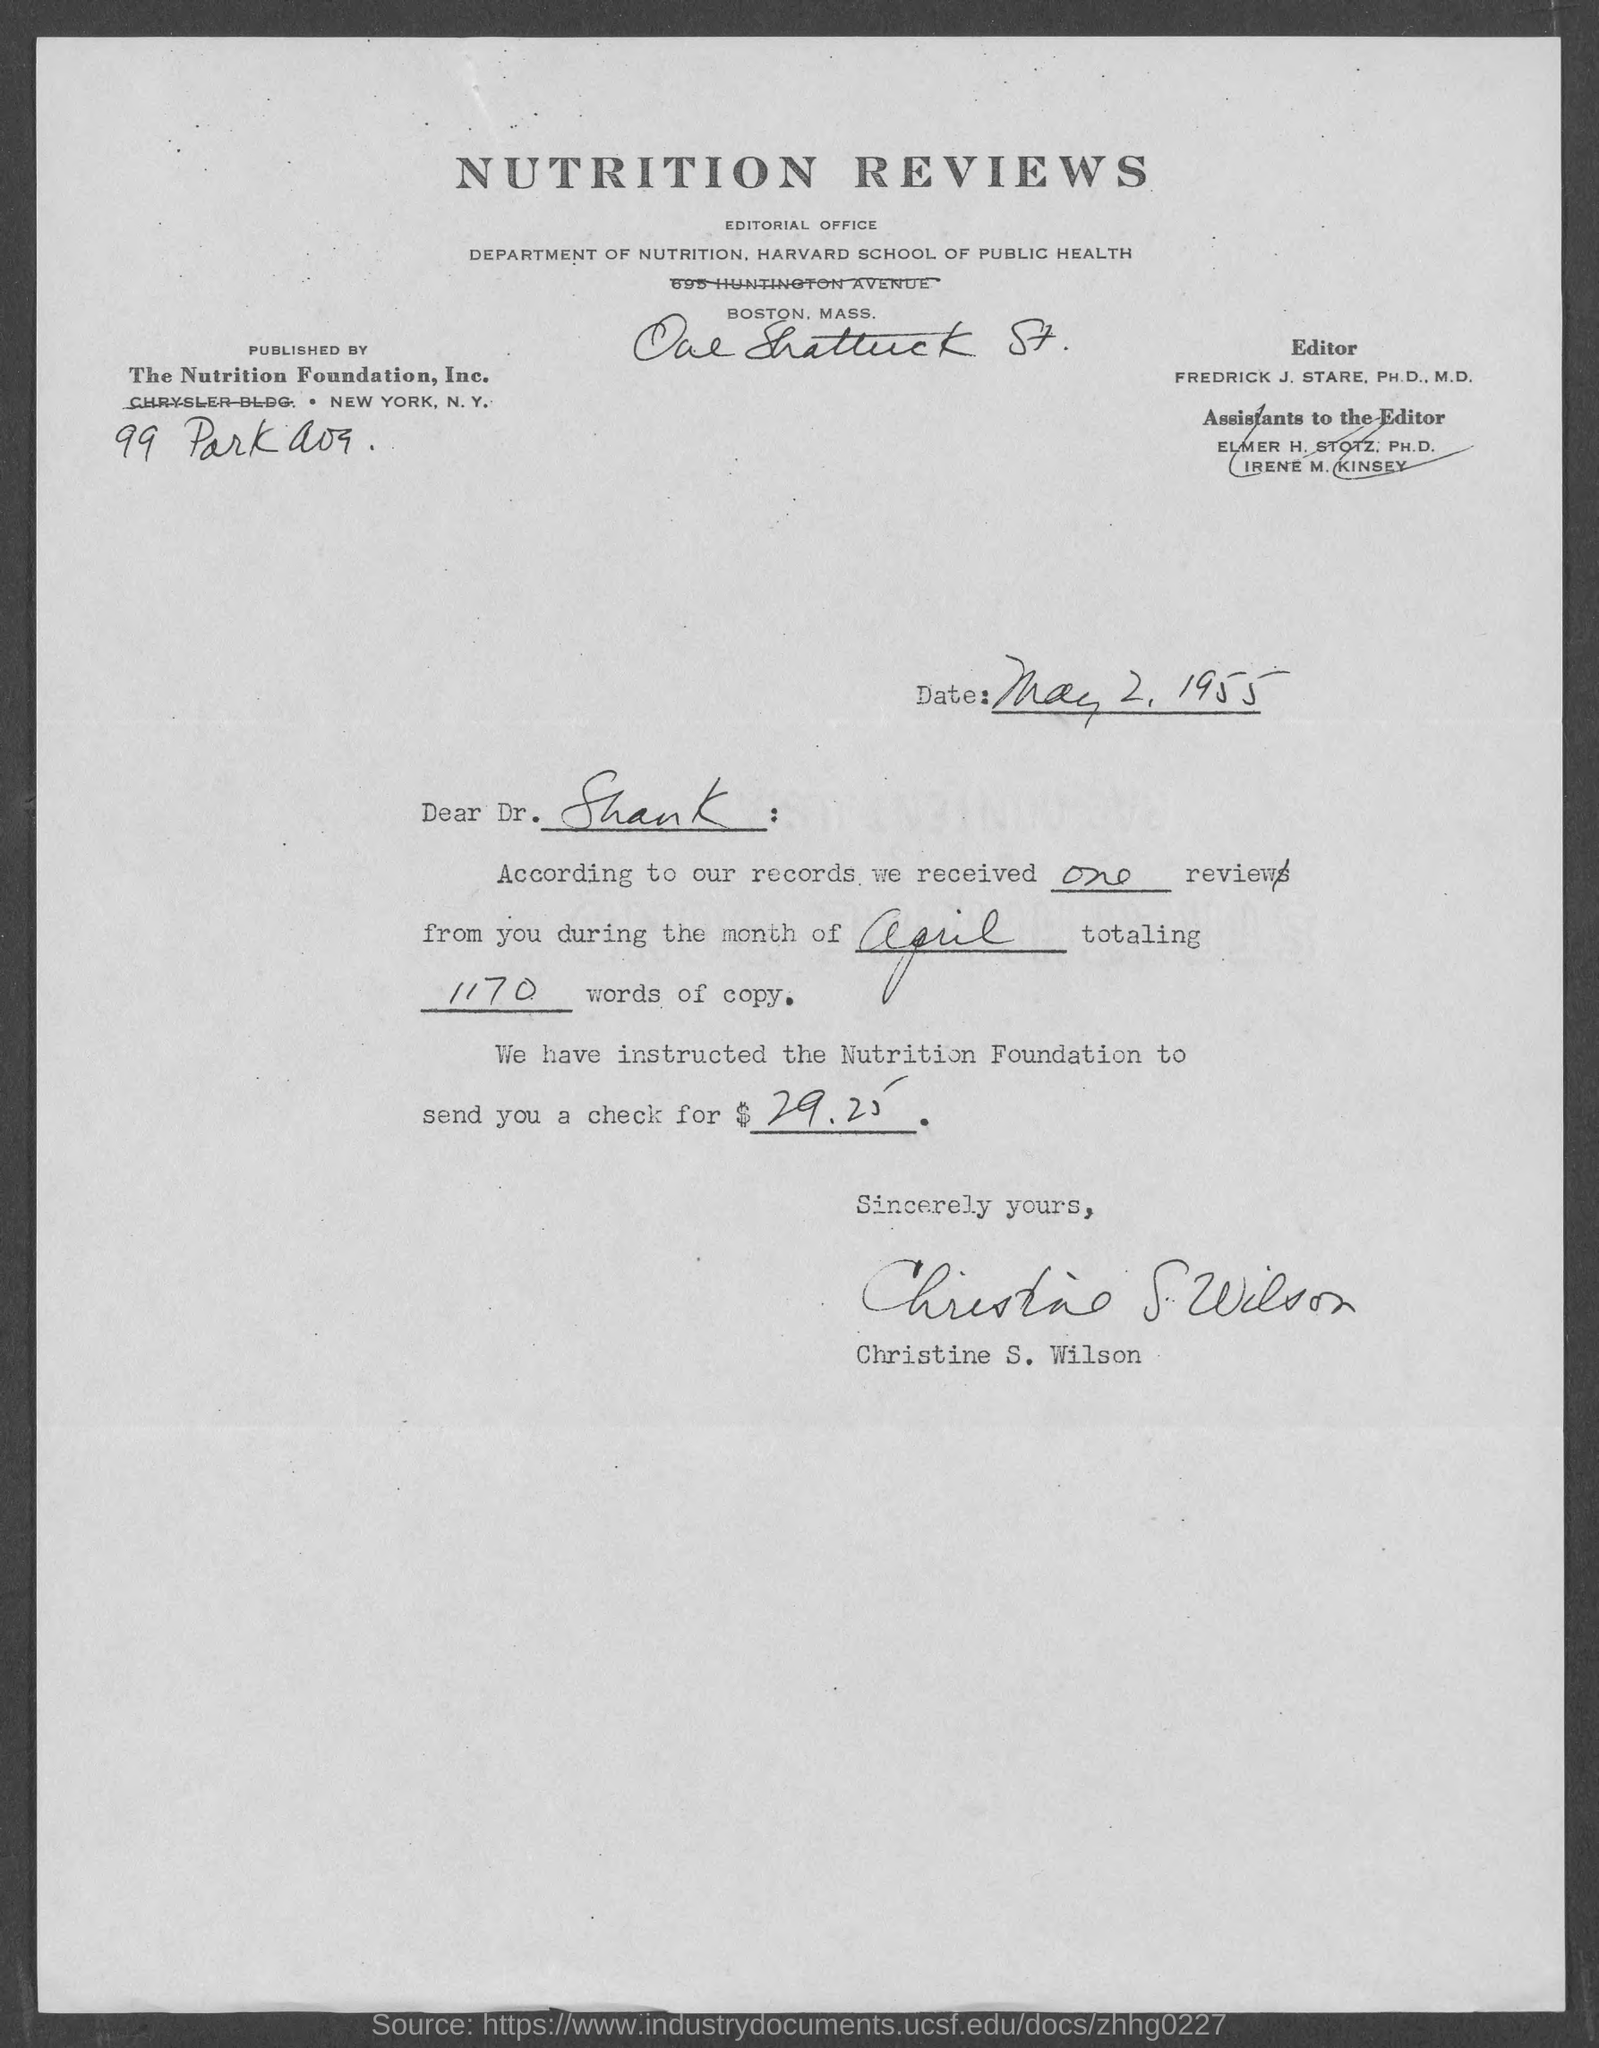Specify some key components in this picture. This letter is addressed to Dr. Shank. The letter is from Christine S. Wilson. The check was for 29.25 dollars. The title of the document is 'Nutrition Reviews.' Fredrick J. Stare, Ph.D., M.D., is the editor. 